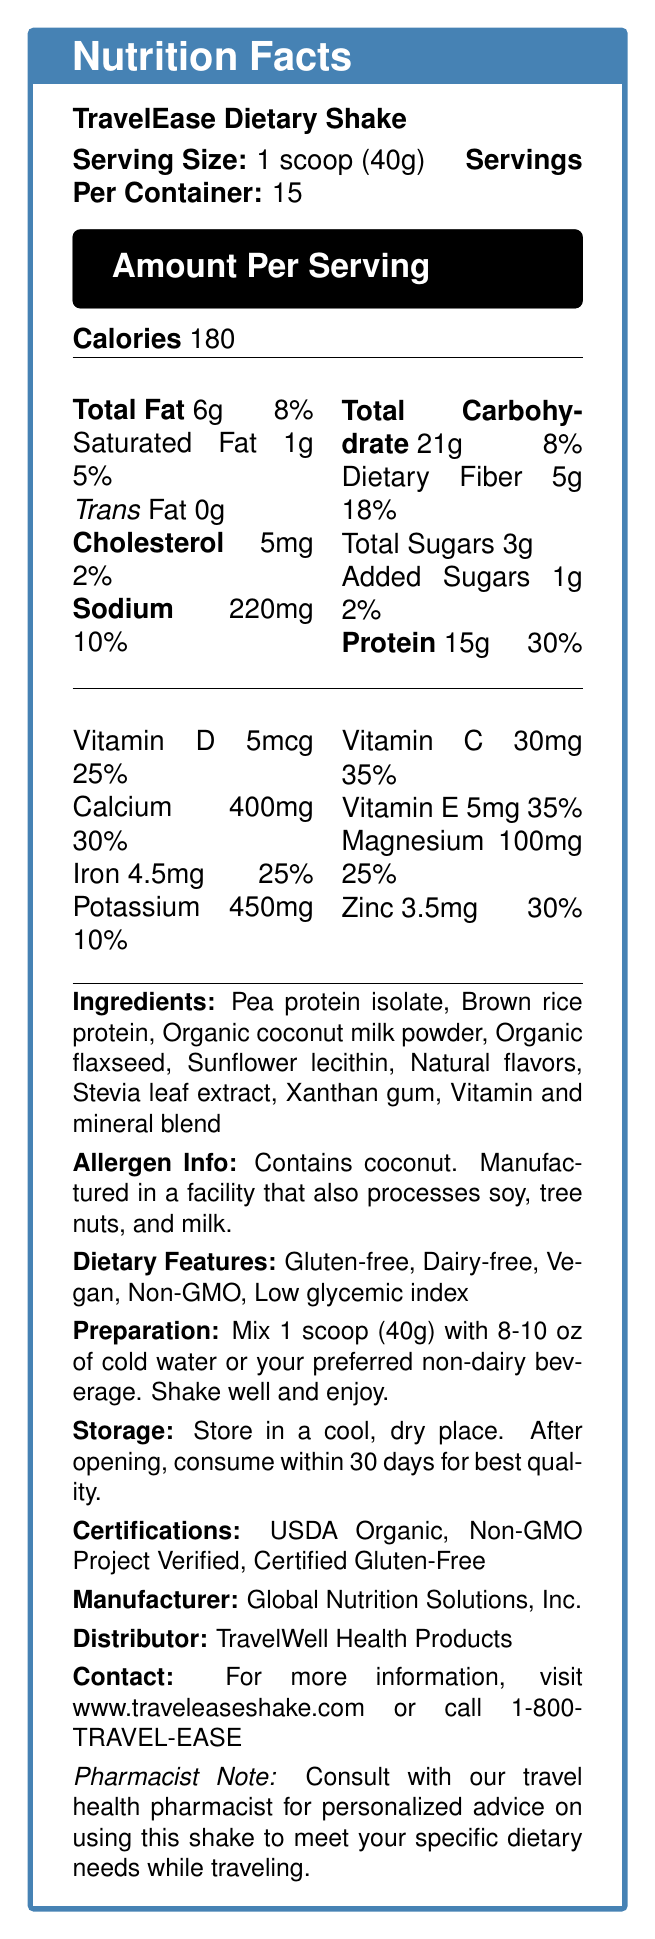what is the serving size of the TravelEase Dietary Shake? The serving size is clearly stated as 1 scoop (40g) in the document.
Answer: 1 scoop (40g) how many servings are there per container? The document states that there are 15 servings per container.
Answer: 15 how many calories are there per serving? The document mentions that there are 180 calories per serving.
Answer: 180 what is the amount of dietary fiber per serving? The dietary fiber content per serving is listed as 5g.
Answer: 5g what percentage of the daily value is provided by the protein content? The protein content provides 30% of the daily value.
Answer: 30% which allergen is explicitly mentioned in the document? A. Soy B. Coconut C. Milk D. Peanuts The allergen information states that the product contains coconut.
Answer: B. Coconut how should the shake be prepared? A. Mix with boiling water B. Blend with ice C. Mix with cold water or preferred non-dairy beverage D. Consume directly The preparation instructions specify mixing 1 scoop with 8-10 oz of cold water or a preferred non-dairy beverage and shaking well.
Answer: C. Mix with cold water or preferred non-dairy beverage what is the main benefit of this product for travelers? A. High protein content B. Gluten-free C. Easily packable D. Vitamin-rich Among the provided travel benefits, "Easily packable" is highlighted as a main benefit for travelers.
Answer: C. Easily packable is this product TSA-compliant in size? The document states that the product is of TSA-compliant size.
Answer: Yes describe the main idea of the document. The document is organized to give a complete understanding of the TravelEase Dietary Shake, covering various aspects from nutritional content and ingredients to preparation and travel-related features.
Answer: The document provides comprehensive information on the TravelEase Dietary Shake, including its nutrition facts, ingredient list, allergen information, dietary features, preparation instructions, storage guidelines, certifications, and benefits for travelers. which facility processes this product? The document mentions that it is manufactured in a facility that processes soy, tree nuts, and milk but does not provide the facility's name or location.
Answer: I don't know 